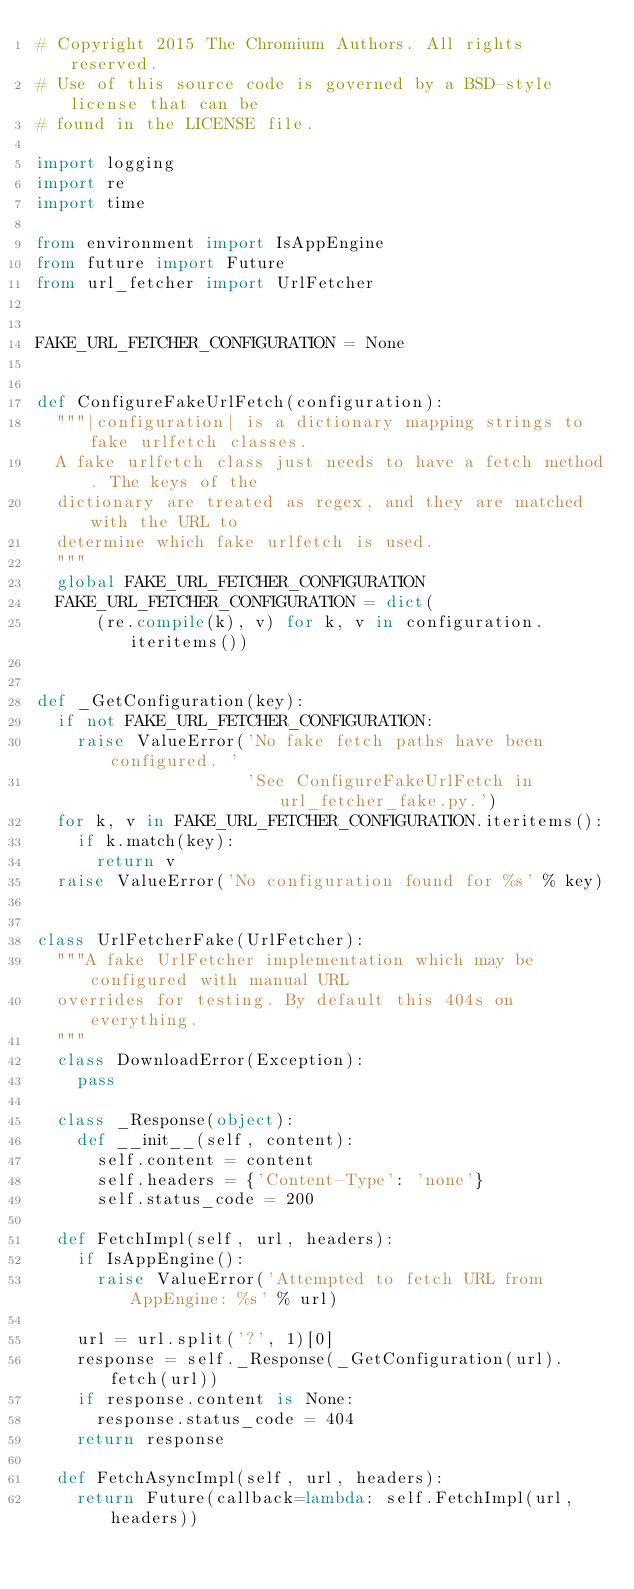<code> <loc_0><loc_0><loc_500><loc_500><_Python_># Copyright 2015 The Chromium Authors. All rights reserved.
# Use of this source code is governed by a BSD-style license that can be
# found in the LICENSE file.

import logging
import re
import time

from environment import IsAppEngine
from future import Future
from url_fetcher import UrlFetcher


FAKE_URL_FETCHER_CONFIGURATION = None


def ConfigureFakeUrlFetch(configuration):
  """|configuration| is a dictionary mapping strings to fake urlfetch classes.
  A fake urlfetch class just needs to have a fetch method. The keys of the
  dictionary are treated as regex, and they are matched with the URL to
  determine which fake urlfetch is used.
  """
  global FAKE_URL_FETCHER_CONFIGURATION
  FAKE_URL_FETCHER_CONFIGURATION = dict(
      (re.compile(k), v) for k, v in configuration.iteritems())


def _GetConfiguration(key):
  if not FAKE_URL_FETCHER_CONFIGURATION:
    raise ValueError('No fake fetch paths have been configured. '
                     'See ConfigureFakeUrlFetch in url_fetcher_fake.py.')
  for k, v in FAKE_URL_FETCHER_CONFIGURATION.iteritems():
    if k.match(key):
      return v
  raise ValueError('No configuration found for %s' % key)


class UrlFetcherFake(UrlFetcher):
  """A fake UrlFetcher implementation which may be configured with manual URL
  overrides for testing. By default this 404s on everything.
  """
  class DownloadError(Exception):
    pass

  class _Response(object):
    def __init__(self, content):
      self.content = content
      self.headers = {'Content-Type': 'none'}
      self.status_code = 200

  def FetchImpl(self, url, headers):
    if IsAppEngine():
      raise ValueError('Attempted to fetch URL from AppEngine: %s' % url)

    url = url.split('?', 1)[0]
    response = self._Response(_GetConfiguration(url).fetch(url))
    if response.content is None:
      response.status_code = 404
    return response

  def FetchAsyncImpl(self, url, headers):
    return Future(callback=lambda: self.FetchImpl(url, headers))
</code> 